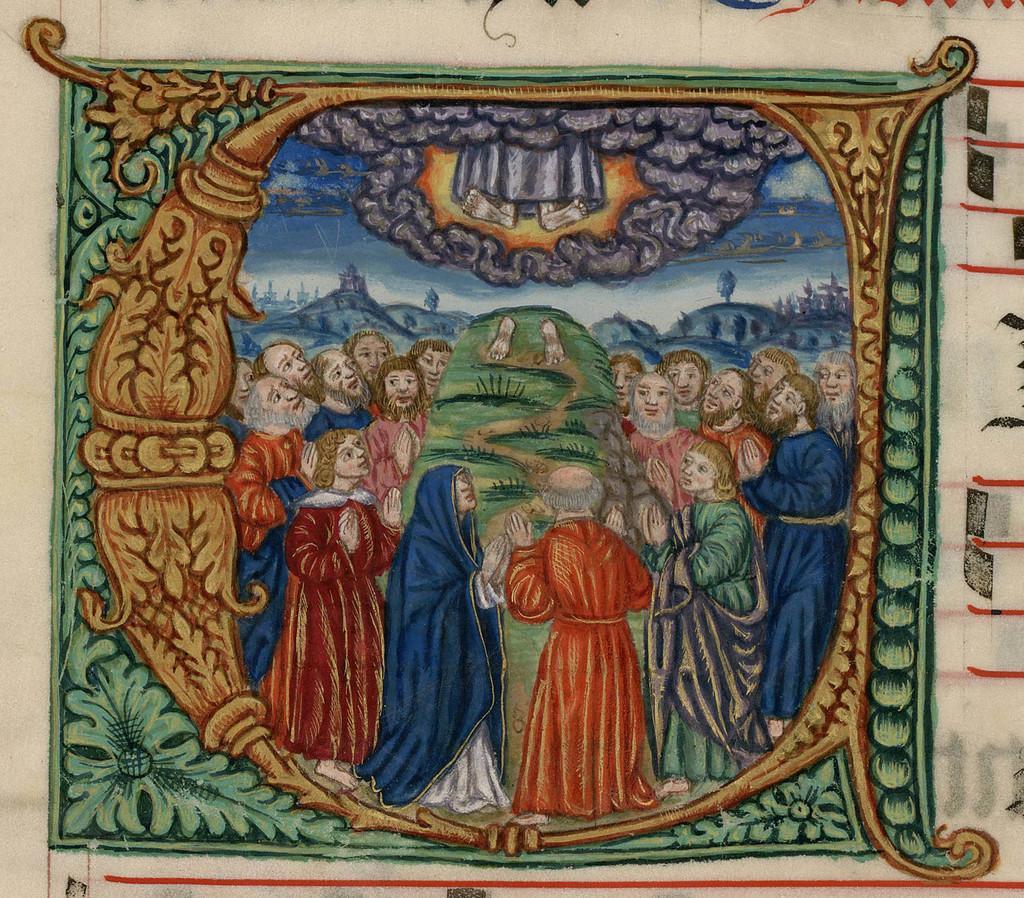Please provide a concise description of this image. In this image I can see a wall painting in which a group of people are standing on the ground, grass, houses and the sky I can see. 